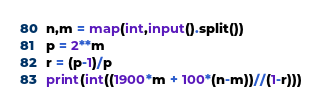<code> <loc_0><loc_0><loc_500><loc_500><_Python_>n,m = map(int,input().split())
p = 2**m
r = (p-1)/p
print(int((1900*m + 100*(n-m))//(1-r)))</code> 